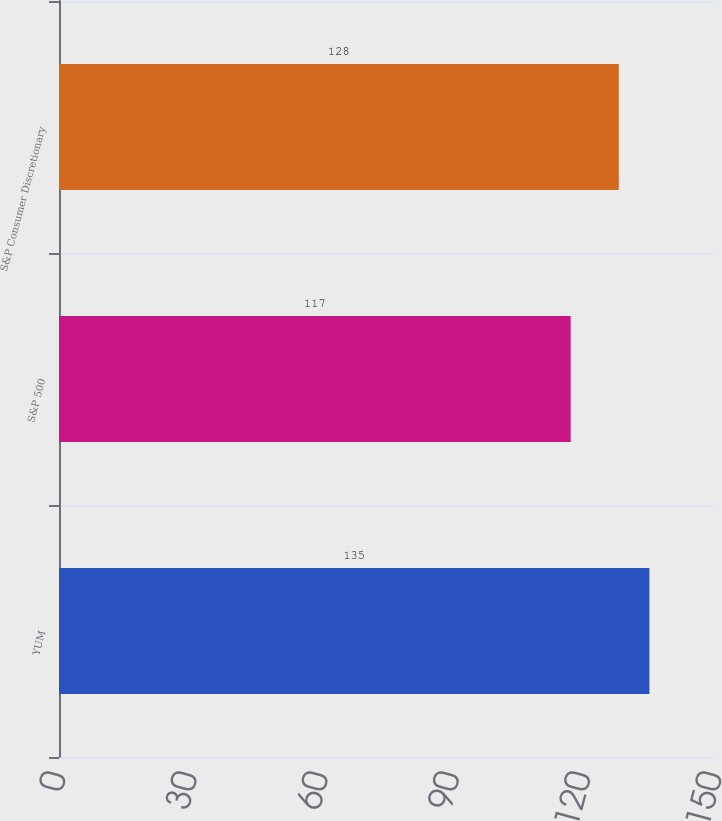<chart> <loc_0><loc_0><loc_500><loc_500><bar_chart><fcel>YUM<fcel>S&P 500<fcel>S&P Consumer Discretionary<nl><fcel>135<fcel>117<fcel>128<nl></chart> 